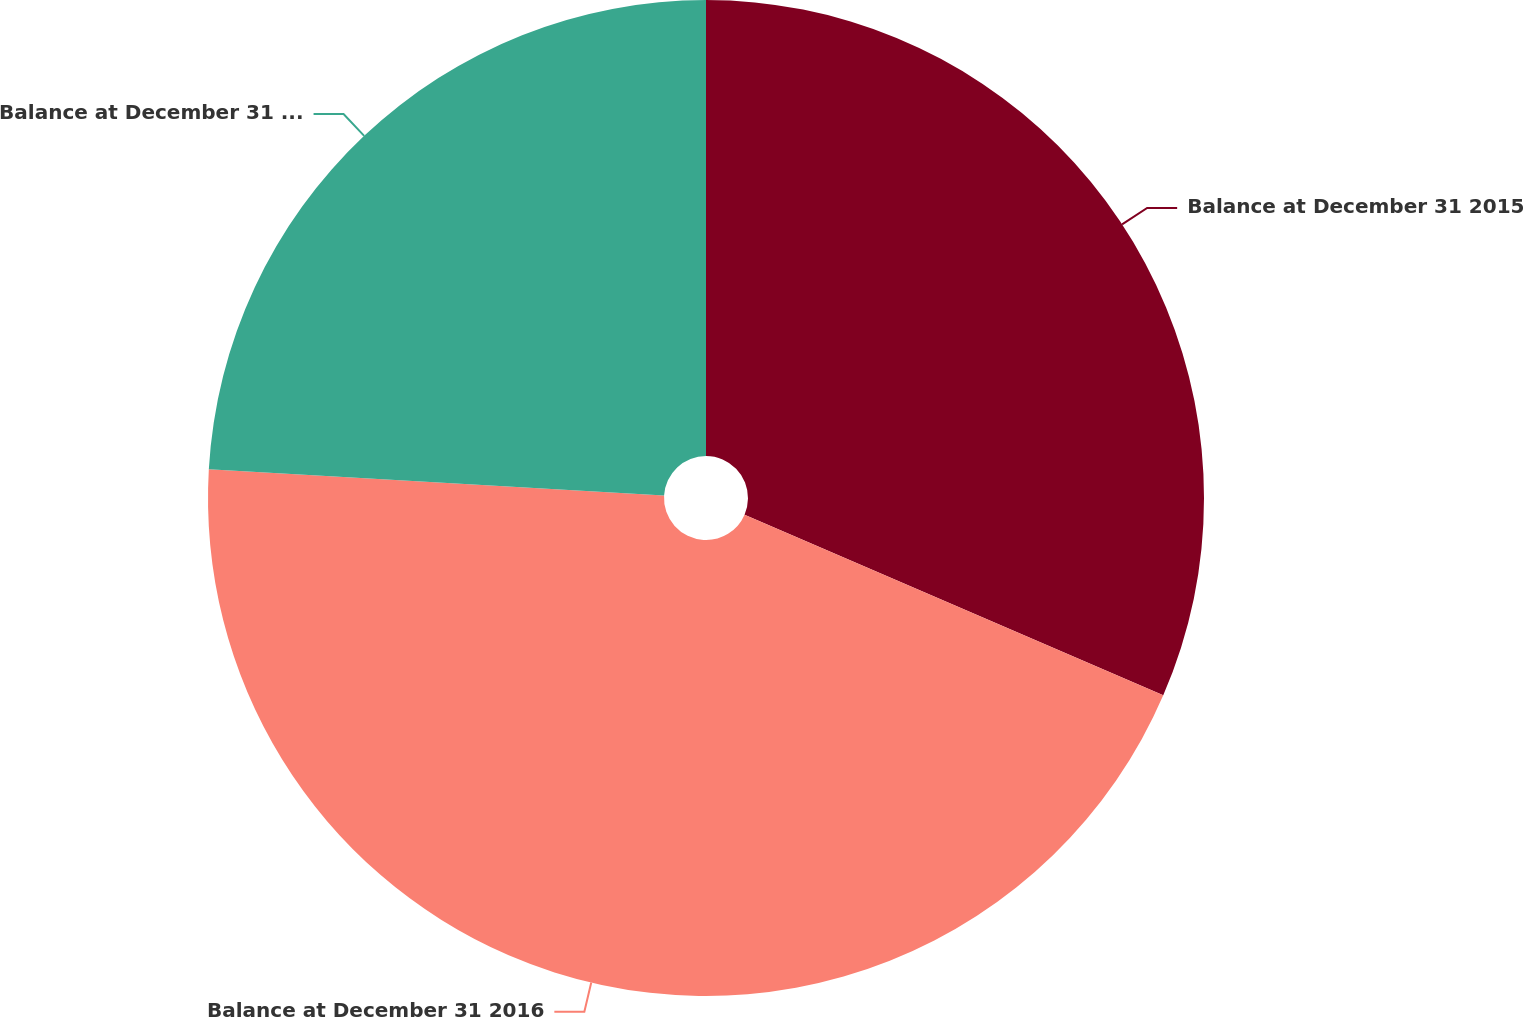Convert chart. <chart><loc_0><loc_0><loc_500><loc_500><pie_chart><fcel>Balance at December 31 2015<fcel>Balance at December 31 2016<fcel>Balance at December 31 2017<nl><fcel>31.48%<fcel>44.43%<fcel>24.08%<nl></chart> 